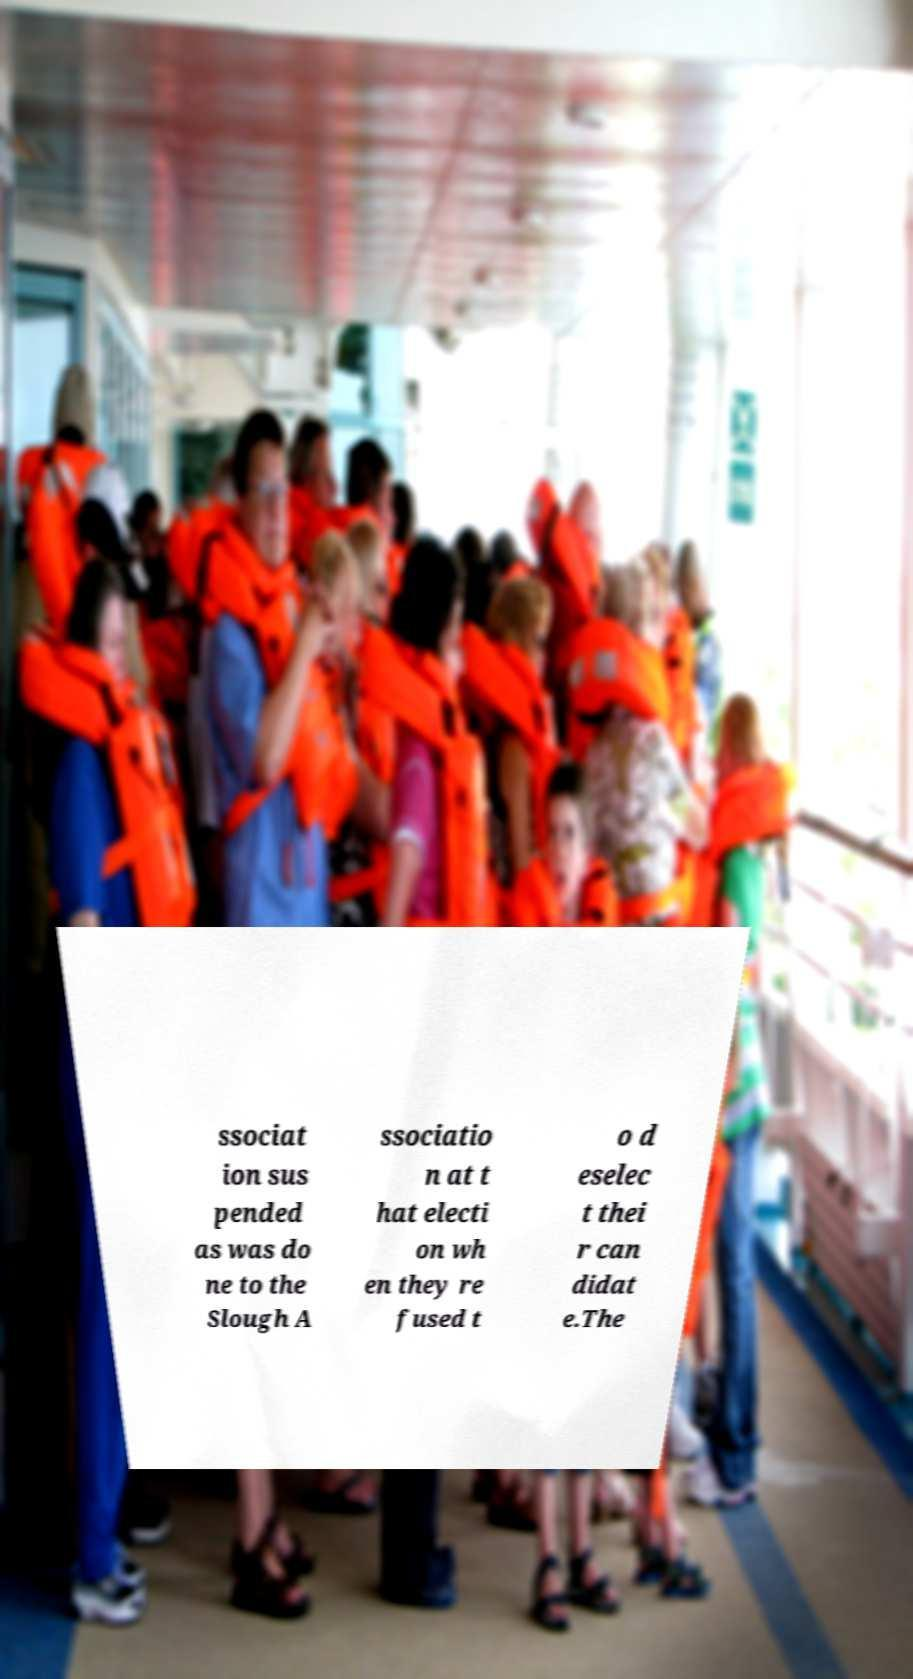Could you extract and type out the text from this image? ssociat ion sus pended as was do ne to the Slough A ssociatio n at t hat electi on wh en they re fused t o d eselec t thei r can didat e.The 